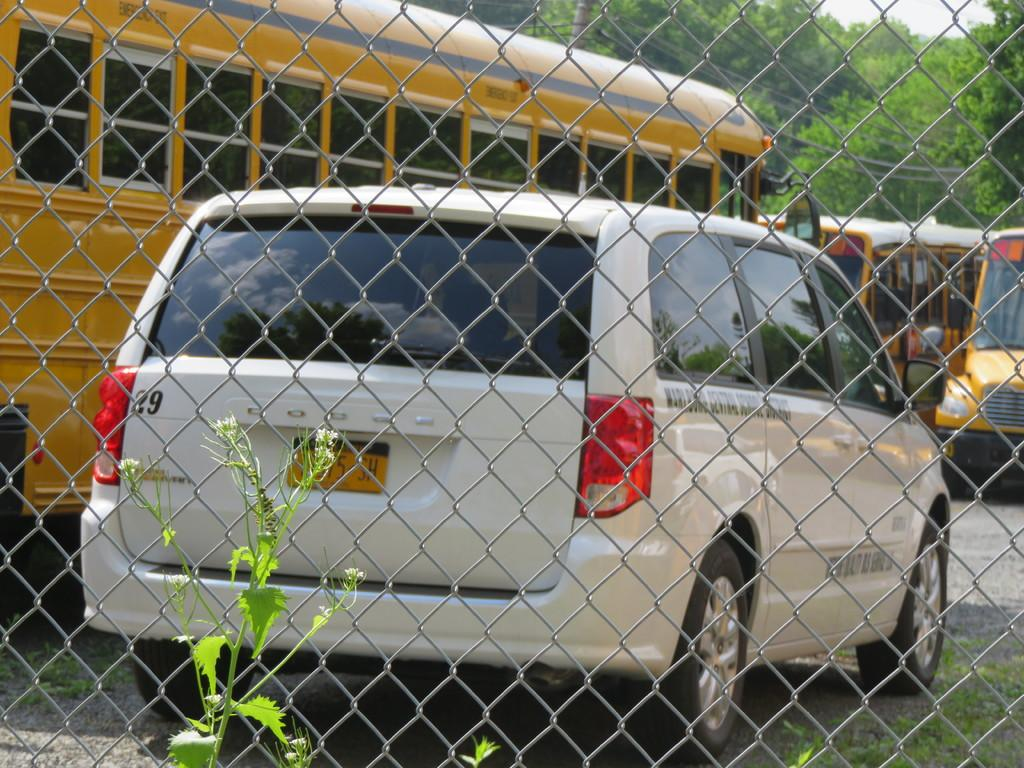What type of material is featured in the image? There is a welded wire mesh in the image. What else can be seen in the image besides the wire mesh? There are vehicles, a plant, and grass visible in the image. What is in the background of the image? There are trees and the sky visible in the background of the image. How many points does the snake have in the image? There is no snake present in the image, so it is not possible to determine the number of points it might have. 